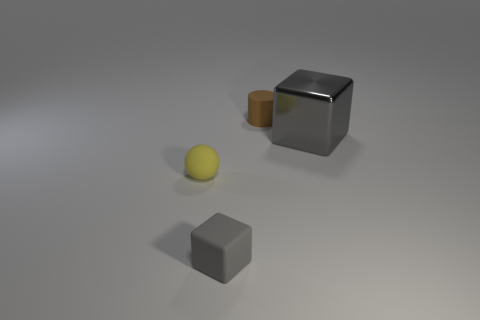There is a gray thing right of the thing behind the gray metal object; what is its shape?
Make the answer very short. Cube. Is there a tiny yellow rubber sphere?
Ensure brevity in your answer.  Yes. What number of matte things are in front of the rubber thing behind the small rubber thing on the left side of the tiny gray matte object?
Provide a succinct answer. 2. Is the shape of the small gray rubber object the same as the rubber thing that is behind the shiny block?
Ensure brevity in your answer.  No. Are there more big metallic cubes than large cyan shiny spheres?
Your answer should be compact. Yes. Is there anything else that is the same size as the rubber block?
Provide a succinct answer. Yes. Do the gray thing to the left of the big gray object and the tiny brown matte object have the same shape?
Make the answer very short. No. Are there more things that are to the right of the brown cylinder than small brown blocks?
Give a very brief answer. Yes. What color is the block that is in front of the gray block that is right of the small cylinder?
Your answer should be very brief. Gray. What number of small yellow matte things are there?
Your answer should be compact. 1. 